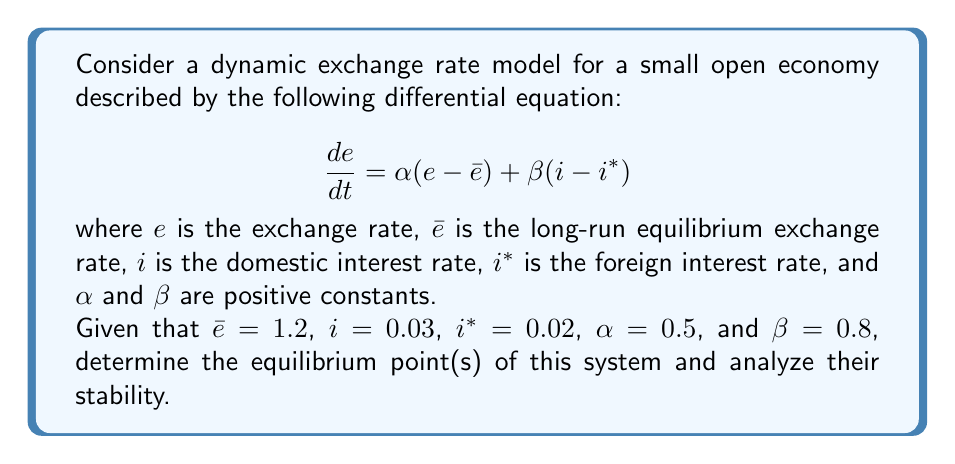What is the answer to this math problem? To solve this problem, we'll follow these steps:

1) First, we need to find the equilibrium point(s). At equilibrium, $\frac{de}{dt} = 0$, so:

   $$ 0 = \alpha(e - \bar{e}) + \beta(i - i^*) $$

2) Substituting the given values:

   $$ 0 = 0.5(e - 1.2) + 0.8(0.03 - 0.02) $$

3) Simplify:

   $$ 0 = 0.5e - 0.6 + 0.008 $$
   $$ 0 = 0.5e - 0.592 $$

4) Solve for $e$:

   $$ 0.5e = 0.592 $$
   $$ e = 1.184 $$

5) This is the equilibrium point of the system.

6) To analyze stability, we need to look at the derivative of $\frac{de}{dt}$ with respect to $e$:

   $$ \frac{d}{de}\left(\frac{de}{dt}\right) = \frac{d}{de}[\alpha(e - \bar{e}) + \beta(i - i^*)] = \alpha $$

7) Since $\alpha = 0.5 > 0$, this indicates that the equilibrium point is unstable. 

   In dynamical systems, if the derivative is positive at the equilibrium point, it means that small deviations from the equilibrium will grow over time, making the equilibrium unstable.

8) Economically, this suggests that if the exchange rate deviates from its equilibrium value of 1.184, it will continue to move away from this value over time, unless there are external interventions or changes in the parameters of the model.
Answer: Equilibrium point: $e = 1.184$. The equilibrium is unstable. 